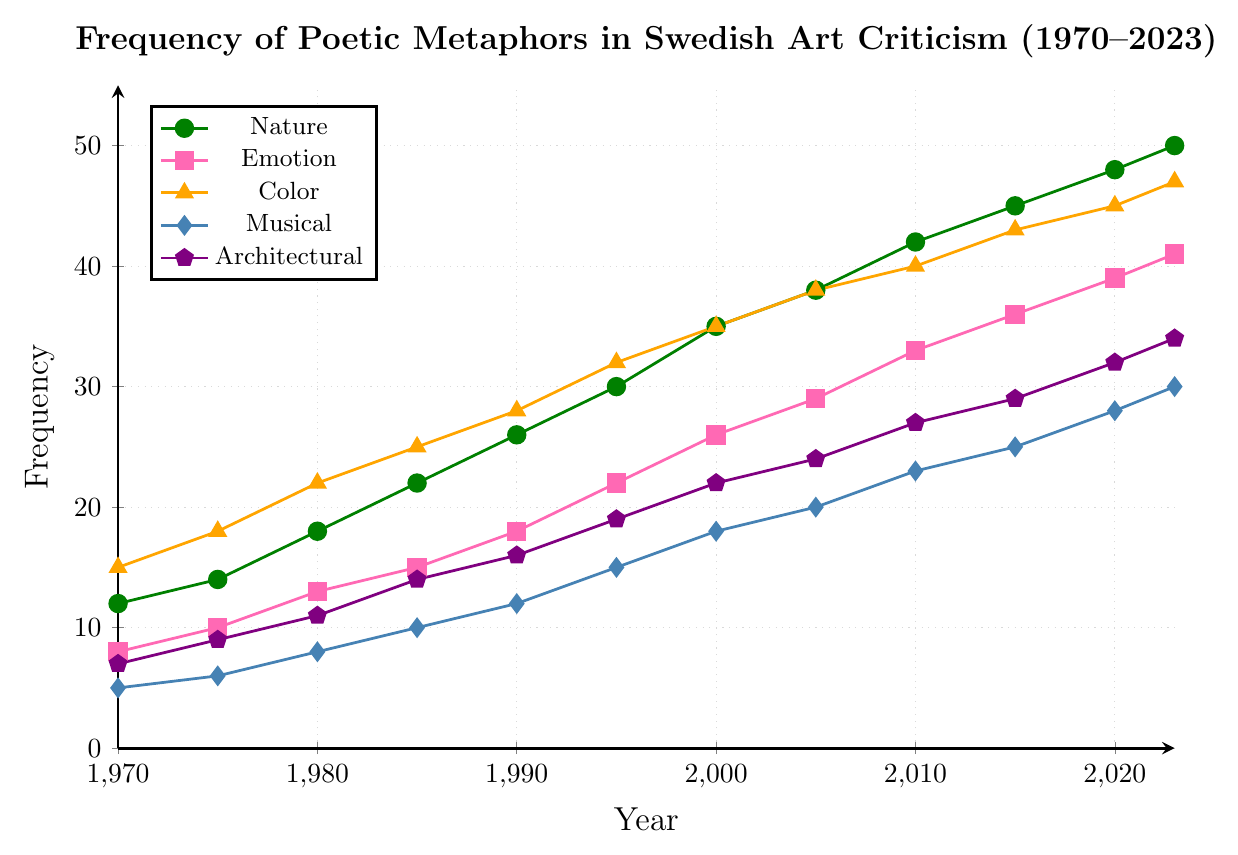Which category had the highest frequency in 2023? By examining the line chart, the 'Color' metaphors category had the highest frequency in 2023, as indicated by the peak of the orange line at 47.
Answer: Color Metaphors How much did the frequency of 'Musical' metaphors increase from 1980 to 2023? The frequency of 'Musical' metaphors in 1980 was 8, and in 2023 it was 30. The increase is calculated as 30 - 8 = 22.
Answer: 22 Which type of metaphor had the lowest frequency in 1990? By inspecting the plot for the year 1990, the 'Musical' metaphors (light blue) had the lowest frequency at 12.
Answer: Musical Metaphors What is the sum of frequencies of 'Nature' and 'Emotion' metaphors in 2010? In 2010, the frequency of 'Nature' metaphors is 42, and 'Emotion' metaphors is 33. The sum is calculated as 42 + 33 = 75.
Answer: 75 Between which years did 'Architectural' metaphors show the highest growth rate? Observing the steepest slope of the purple line on the chart helps identify the highest growth rate. The sharpest increase for 'Architectural' metaphors happens between 1990 and 1995, where the frequency jumps from 16 to 19.
Answer: 1990-1995 How does the trend for 'Emotion' metaphors compare to 'Nature' metaphors over the entire period? Both 'Emotion' (pink) and 'Nature' (green) metaphors show an increasing trend, but 'Nature' metaphors maintain a consistently higher frequency compared to 'Emotion' metaphors over the period from 1970 to 2023.
Answer: 'Nature' > 'Emotion' What is the average frequency of 'Architectural' metaphors over the period shown? The frequencies of 'Architectural' metaphors over the years are: 7, 9, 11, 14, 16, 19, 22, 24, 27, 29, 32, 34. The sum is 244. The average is calculated as 244/12 = 20.33.
Answer: 20.33 Which metaphor category reached a frequency of 40 first, and in what year? By tracing the lines, the 'Color' metaphors category first reached a frequency of 40 in 2010, as depicted by the orange line hitting 40.
Answer: Color Metaphors; 2010 What is the frequency difference between 'Nature' and 'Emotion' metaphors in 1995? In 1995, the frequency of 'Nature' metaphors is 30, and 'Emotion' metaphors is 22. The difference is calculated as 30 - 22 = 8.
Answer: 8 Which two categories almost converge in frequency in 2023, and what are their frequencies? By observing the endpoints of the lines in 2023, 'Nature' (green, frequency 50) and 'Color' (orange, frequency 47) metaphors are the closest in frequency.
Answer: Nature: 50, Color: 47 